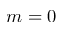Convert formula to latex. <formula><loc_0><loc_0><loc_500><loc_500>m = 0</formula> 